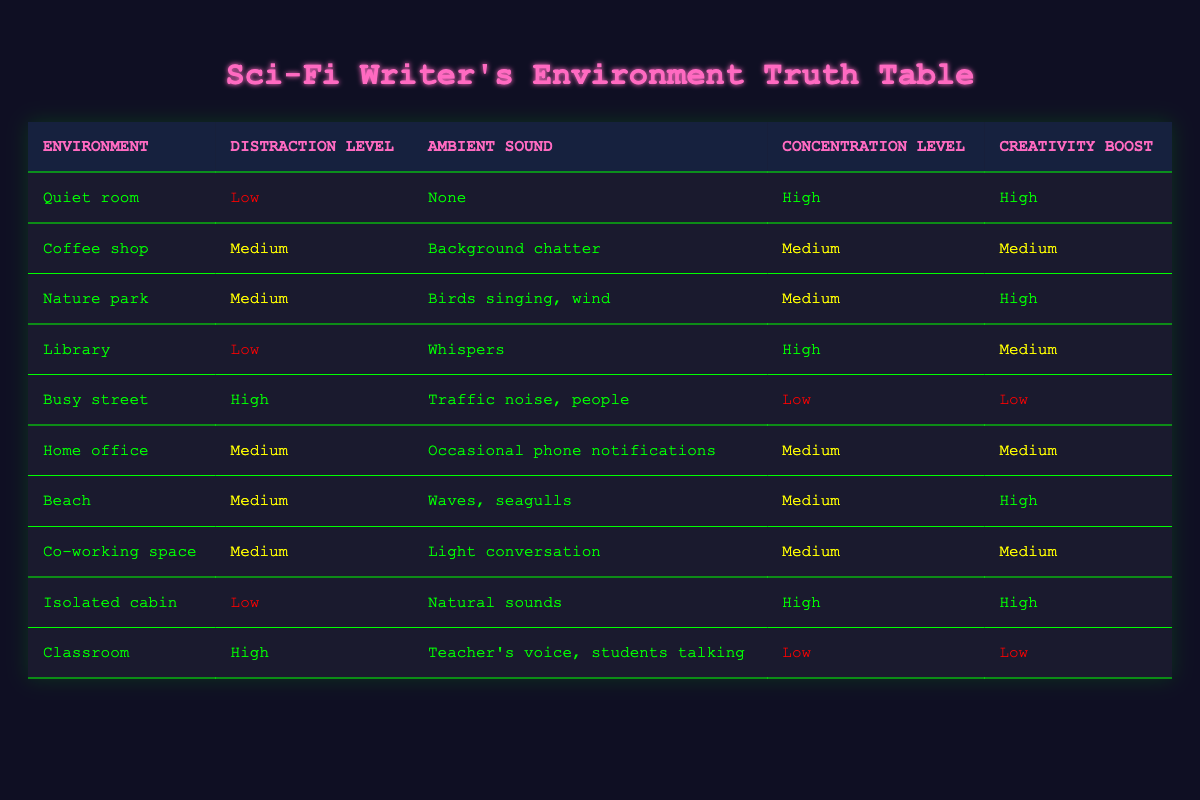What is the concentration level in a Quiet room? The table lists the concentration level for the Quiet room as "High" under the concentration level column.
Answer: High Which writing environment has the lowest distraction level? By checking the distraction level column, the environments with the lowest distraction level are the Quiet room, Library, and Isolated cabin, all marked as "Low".
Answer: Quiet room, Library, Isolated cabin Which environment has the highest creativity boost? Looking across the creativity boost column, the Quiet room and Isolated cabin both have a "High" creativity boost.
Answer: Quiet room, Isolated cabin How many environments have a medium concentration level? The environments with a medium concentration level are Coffee shop, Nature park, Home office, Beach, and Co-working space. Counting these gives a total of 5.
Answer: 5 Is the concentration level in a Busy street High? The table indicates that the concentration level in a Busy street is "Low," thus the statement is false.
Answer: No Which environment has both a Low distraction level and a High creativity boost? The environments with Low distraction levels and High creativity boosts are the Quiet room and Isolated cabin.
Answer: Quiet room, Isolated cabin If we consider environments with a Medium creativity boost, what are their names? From the table, the environments that have a Medium creativity boost are Coffee shop, Home office, Library, and Co-working space.
Answer: Coffee shop, Home office, Library, Co-working space What is the average distraction level across all environments? The distraction levels can be categorized: Low (3), Medium (4), High (3). Assigning numerical values gives Low=1, Medium=2, and High=3. The average is calculated as (1*3 + 2*4 + 3*3) / 10 = (3 + 8 + 9) / 10 = 20 / 10 = 2, which corresponds to Medium.
Answer: Medium Which environment has Natural sounds as the ambient sound? Referring to the ambient sound column, the Isolated cabin has "Natural sounds" listed as its ambient sound.
Answer: Isolated cabin 